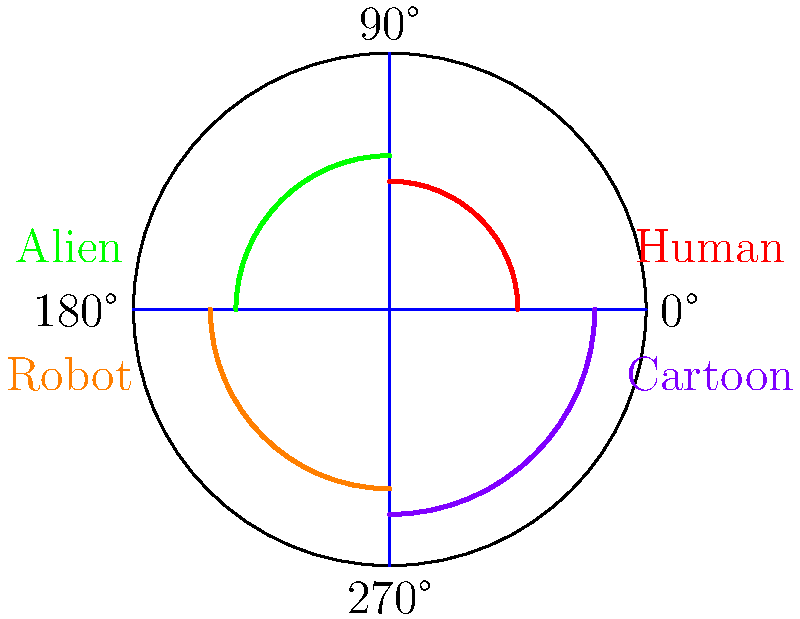As a voice actor providing feedback on character designs, you're presented with a diagram showing the range of motion for different character types' shoulder joints. Which character type has the most restricted range of motion, and approximately what is its maximum rotation angle? To answer this question, let's analyze the diagram step-by-step:

1. The circle represents a top-down view of a shoulder joint, with 0° at the right and increasing counterclockwise.

2. Each colored arc represents the range of motion for a different character type:
   - Red arc (0° to 90°): Human
   - Green arc (90° to 180°): Alien
   - Orange arc (180° to 270°): Robot
   - Purple arc (270° to 360°): Cartoon

3. To find the most restricted range of motion, we need to identify the smallest arc:
   - Human: 90° (1/4 of the circle)
   - Alien: 90° (1/4 of the circle)
   - Robot: 90° (1/4 of the circle)
   - Cartoon: 90° (1/4 of the circle)

4. All character types have the same range of motion (90°), but they differ in their starting and ending positions.

5. The robot's range of motion is from 180° to 270°, which corresponds to moving the arm from pointing left to pointing down.

Therefore, while all character types have the same restricted range of motion, the robot's movement is limited to a 90° rotation starting from the left side (180°) and ending at the bottom (270°).
Answer: Robot, 90° 